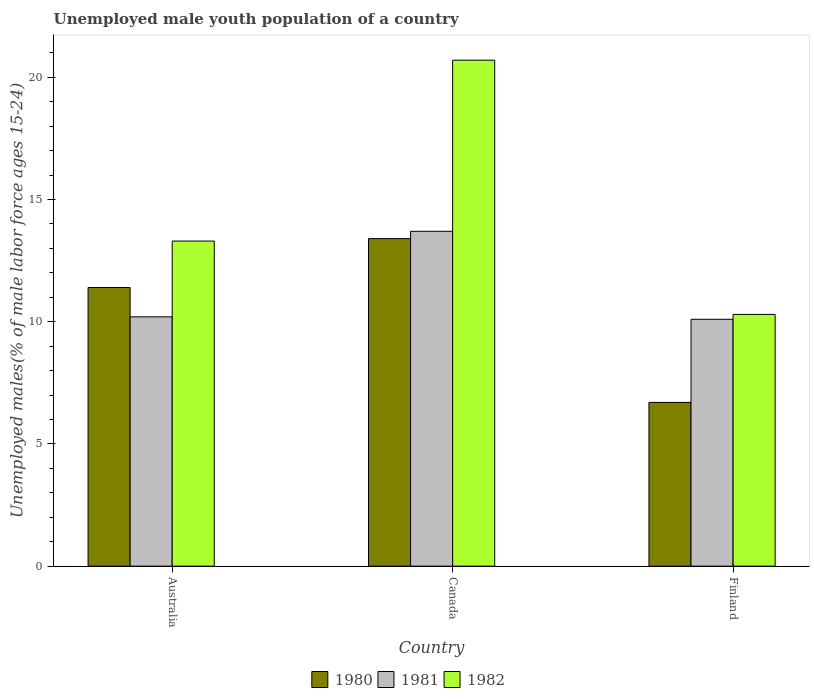How many groups of bars are there?
Keep it short and to the point. 3. How many bars are there on the 2nd tick from the right?
Provide a succinct answer. 3. What is the percentage of unemployed male youth population in 1980 in Canada?
Offer a terse response. 13.4. Across all countries, what is the maximum percentage of unemployed male youth population in 1982?
Provide a succinct answer. 20.7. Across all countries, what is the minimum percentage of unemployed male youth population in 1982?
Offer a terse response. 10.3. In which country was the percentage of unemployed male youth population in 1980 maximum?
Offer a very short reply. Canada. In which country was the percentage of unemployed male youth population in 1980 minimum?
Your answer should be compact. Finland. What is the total percentage of unemployed male youth population in 1980 in the graph?
Provide a short and direct response. 31.5. What is the difference between the percentage of unemployed male youth population in 1980 in Canada and that in Finland?
Your answer should be very brief. 6.7. What is the difference between the percentage of unemployed male youth population in 1982 in Finland and the percentage of unemployed male youth population in 1981 in Canada?
Your response must be concise. -3.4. What is the average percentage of unemployed male youth population in 1981 per country?
Provide a succinct answer. 11.33. What is the difference between the percentage of unemployed male youth population of/in 1980 and percentage of unemployed male youth population of/in 1981 in Australia?
Provide a short and direct response. 1.2. In how many countries, is the percentage of unemployed male youth population in 1980 greater than 2 %?
Keep it short and to the point. 3. What is the ratio of the percentage of unemployed male youth population in 1981 in Australia to that in Finland?
Offer a very short reply. 1.01. Is the percentage of unemployed male youth population in 1981 in Canada less than that in Finland?
Give a very brief answer. No. What is the difference between the highest and the second highest percentage of unemployed male youth population in 1982?
Provide a short and direct response. -10.4. What is the difference between the highest and the lowest percentage of unemployed male youth population in 1982?
Your answer should be compact. 10.4. What does the 2nd bar from the left in Australia represents?
Ensure brevity in your answer.  1981. Is it the case that in every country, the sum of the percentage of unemployed male youth population in 1980 and percentage of unemployed male youth population in 1981 is greater than the percentage of unemployed male youth population in 1982?
Keep it short and to the point. Yes. Are all the bars in the graph horizontal?
Your answer should be very brief. No. How many countries are there in the graph?
Your response must be concise. 3. What is the difference between two consecutive major ticks on the Y-axis?
Provide a short and direct response. 5. Does the graph contain grids?
Your response must be concise. No. Where does the legend appear in the graph?
Make the answer very short. Bottom center. How are the legend labels stacked?
Make the answer very short. Horizontal. What is the title of the graph?
Keep it short and to the point. Unemployed male youth population of a country. What is the label or title of the Y-axis?
Your response must be concise. Unemployed males(% of male labor force ages 15-24). What is the Unemployed males(% of male labor force ages 15-24) in 1980 in Australia?
Offer a very short reply. 11.4. What is the Unemployed males(% of male labor force ages 15-24) in 1981 in Australia?
Give a very brief answer. 10.2. What is the Unemployed males(% of male labor force ages 15-24) in 1982 in Australia?
Your response must be concise. 13.3. What is the Unemployed males(% of male labor force ages 15-24) in 1980 in Canada?
Your answer should be compact. 13.4. What is the Unemployed males(% of male labor force ages 15-24) in 1981 in Canada?
Ensure brevity in your answer.  13.7. What is the Unemployed males(% of male labor force ages 15-24) in 1982 in Canada?
Make the answer very short. 20.7. What is the Unemployed males(% of male labor force ages 15-24) in 1980 in Finland?
Keep it short and to the point. 6.7. What is the Unemployed males(% of male labor force ages 15-24) of 1981 in Finland?
Your response must be concise. 10.1. What is the Unemployed males(% of male labor force ages 15-24) of 1982 in Finland?
Offer a terse response. 10.3. Across all countries, what is the maximum Unemployed males(% of male labor force ages 15-24) of 1980?
Offer a very short reply. 13.4. Across all countries, what is the maximum Unemployed males(% of male labor force ages 15-24) of 1981?
Ensure brevity in your answer.  13.7. Across all countries, what is the maximum Unemployed males(% of male labor force ages 15-24) in 1982?
Keep it short and to the point. 20.7. Across all countries, what is the minimum Unemployed males(% of male labor force ages 15-24) in 1980?
Give a very brief answer. 6.7. Across all countries, what is the minimum Unemployed males(% of male labor force ages 15-24) of 1981?
Provide a succinct answer. 10.1. Across all countries, what is the minimum Unemployed males(% of male labor force ages 15-24) in 1982?
Your answer should be compact. 10.3. What is the total Unemployed males(% of male labor force ages 15-24) in 1980 in the graph?
Give a very brief answer. 31.5. What is the total Unemployed males(% of male labor force ages 15-24) of 1982 in the graph?
Give a very brief answer. 44.3. What is the difference between the Unemployed males(% of male labor force ages 15-24) in 1981 in Australia and that in Canada?
Ensure brevity in your answer.  -3.5. What is the difference between the Unemployed males(% of male labor force ages 15-24) of 1982 in Australia and that in Canada?
Give a very brief answer. -7.4. What is the difference between the Unemployed males(% of male labor force ages 15-24) of 1981 in Australia and that in Finland?
Offer a terse response. 0.1. What is the difference between the Unemployed males(% of male labor force ages 15-24) of 1981 in Canada and that in Finland?
Provide a succinct answer. 3.6. What is the difference between the Unemployed males(% of male labor force ages 15-24) of 1980 in Australia and the Unemployed males(% of male labor force ages 15-24) of 1981 in Canada?
Provide a succinct answer. -2.3. What is the difference between the Unemployed males(% of male labor force ages 15-24) of 1980 in Australia and the Unemployed males(% of male labor force ages 15-24) of 1982 in Canada?
Keep it short and to the point. -9.3. What is the difference between the Unemployed males(% of male labor force ages 15-24) in 1980 in Australia and the Unemployed males(% of male labor force ages 15-24) in 1981 in Finland?
Ensure brevity in your answer.  1.3. What is the difference between the Unemployed males(% of male labor force ages 15-24) of 1980 in Australia and the Unemployed males(% of male labor force ages 15-24) of 1982 in Finland?
Offer a very short reply. 1.1. What is the difference between the Unemployed males(% of male labor force ages 15-24) of 1981 in Australia and the Unemployed males(% of male labor force ages 15-24) of 1982 in Finland?
Your answer should be compact. -0.1. What is the difference between the Unemployed males(% of male labor force ages 15-24) of 1980 in Canada and the Unemployed males(% of male labor force ages 15-24) of 1981 in Finland?
Offer a very short reply. 3.3. What is the difference between the Unemployed males(% of male labor force ages 15-24) in 1980 in Canada and the Unemployed males(% of male labor force ages 15-24) in 1982 in Finland?
Keep it short and to the point. 3.1. What is the difference between the Unemployed males(% of male labor force ages 15-24) of 1981 in Canada and the Unemployed males(% of male labor force ages 15-24) of 1982 in Finland?
Make the answer very short. 3.4. What is the average Unemployed males(% of male labor force ages 15-24) of 1981 per country?
Provide a succinct answer. 11.33. What is the average Unemployed males(% of male labor force ages 15-24) of 1982 per country?
Your response must be concise. 14.77. What is the difference between the Unemployed males(% of male labor force ages 15-24) of 1980 and Unemployed males(% of male labor force ages 15-24) of 1982 in Australia?
Provide a succinct answer. -1.9. What is the difference between the Unemployed males(% of male labor force ages 15-24) in 1981 and Unemployed males(% of male labor force ages 15-24) in 1982 in Australia?
Give a very brief answer. -3.1. What is the difference between the Unemployed males(% of male labor force ages 15-24) in 1980 and Unemployed males(% of male labor force ages 15-24) in 1982 in Canada?
Ensure brevity in your answer.  -7.3. What is the difference between the Unemployed males(% of male labor force ages 15-24) in 1981 and Unemployed males(% of male labor force ages 15-24) in 1982 in Finland?
Your answer should be compact. -0.2. What is the ratio of the Unemployed males(% of male labor force ages 15-24) in 1980 in Australia to that in Canada?
Provide a succinct answer. 0.85. What is the ratio of the Unemployed males(% of male labor force ages 15-24) in 1981 in Australia to that in Canada?
Ensure brevity in your answer.  0.74. What is the ratio of the Unemployed males(% of male labor force ages 15-24) of 1982 in Australia to that in Canada?
Keep it short and to the point. 0.64. What is the ratio of the Unemployed males(% of male labor force ages 15-24) of 1980 in Australia to that in Finland?
Provide a succinct answer. 1.7. What is the ratio of the Unemployed males(% of male labor force ages 15-24) in 1981 in Australia to that in Finland?
Your response must be concise. 1.01. What is the ratio of the Unemployed males(% of male labor force ages 15-24) of 1982 in Australia to that in Finland?
Ensure brevity in your answer.  1.29. What is the ratio of the Unemployed males(% of male labor force ages 15-24) of 1981 in Canada to that in Finland?
Make the answer very short. 1.36. What is the ratio of the Unemployed males(% of male labor force ages 15-24) in 1982 in Canada to that in Finland?
Provide a succinct answer. 2.01. What is the difference between the highest and the second highest Unemployed males(% of male labor force ages 15-24) of 1982?
Your response must be concise. 7.4. What is the difference between the highest and the lowest Unemployed males(% of male labor force ages 15-24) of 1980?
Your answer should be very brief. 6.7. What is the difference between the highest and the lowest Unemployed males(% of male labor force ages 15-24) of 1981?
Give a very brief answer. 3.6. 